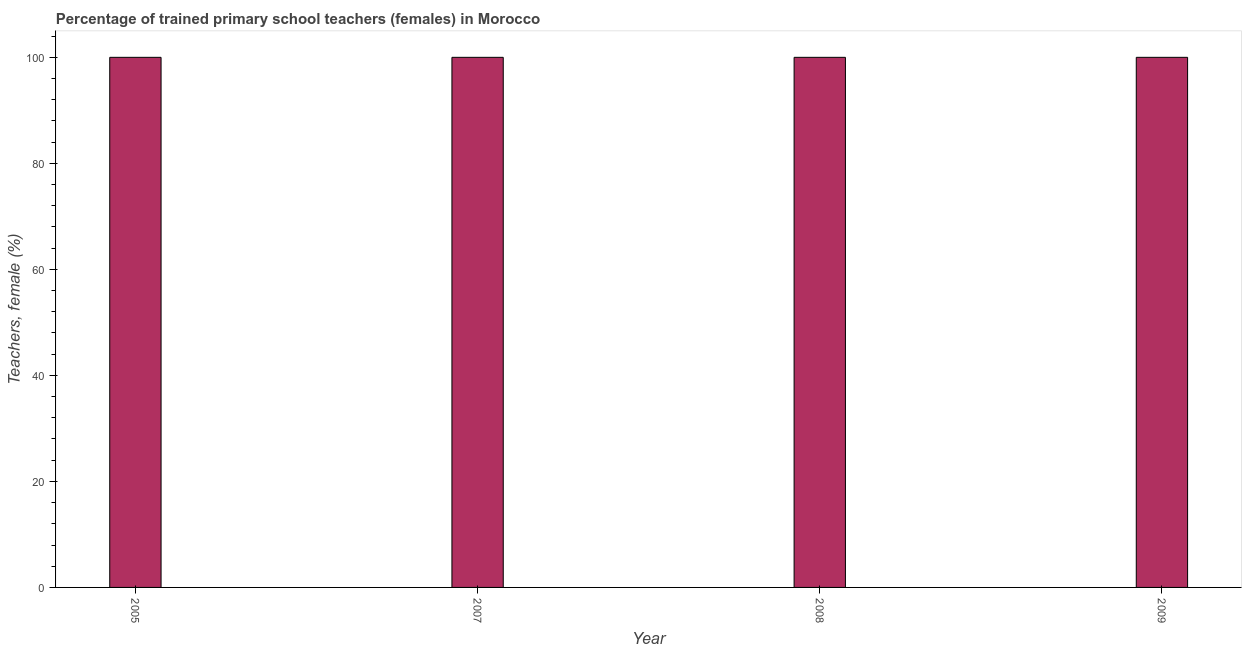Does the graph contain any zero values?
Your answer should be very brief. No. Does the graph contain grids?
Offer a terse response. No. What is the title of the graph?
Make the answer very short. Percentage of trained primary school teachers (females) in Morocco. What is the label or title of the Y-axis?
Keep it short and to the point. Teachers, female (%). Across all years, what is the minimum percentage of trained female teachers?
Offer a terse response. 100. In which year was the percentage of trained female teachers minimum?
Make the answer very short. 2005. What is the average percentage of trained female teachers per year?
Provide a short and direct response. 100. What is the median percentage of trained female teachers?
Your response must be concise. 100. In how many years, is the percentage of trained female teachers greater than 16 %?
Your answer should be compact. 4. Is the percentage of trained female teachers in 2008 less than that in 2009?
Ensure brevity in your answer.  No. In how many years, is the percentage of trained female teachers greater than the average percentage of trained female teachers taken over all years?
Offer a very short reply. 0. How many bars are there?
Give a very brief answer. 4. Are all the bars in the graph horizontal?
Keep it short and to the point. No. What is the difference between two consecutive major ticks on the Y-axis?
Your answer should be very brief. 20. What is the Teachers, female (%) in 2007?
Your response must be concise. 100. What is the Teachers, female (%) of 2008?
Offer a terse response. 100. What is the difference between the Teachers, female (%) in 2005 and 2008?
Give a very brief answer. 0. What is the difference between the Teachers, female (%) in 2005 and 2009?
Give a very brief answer. 0. What is the difference between the Teachers, female (%) in 2008 and 2009?
Your answer should be compact. 0. 